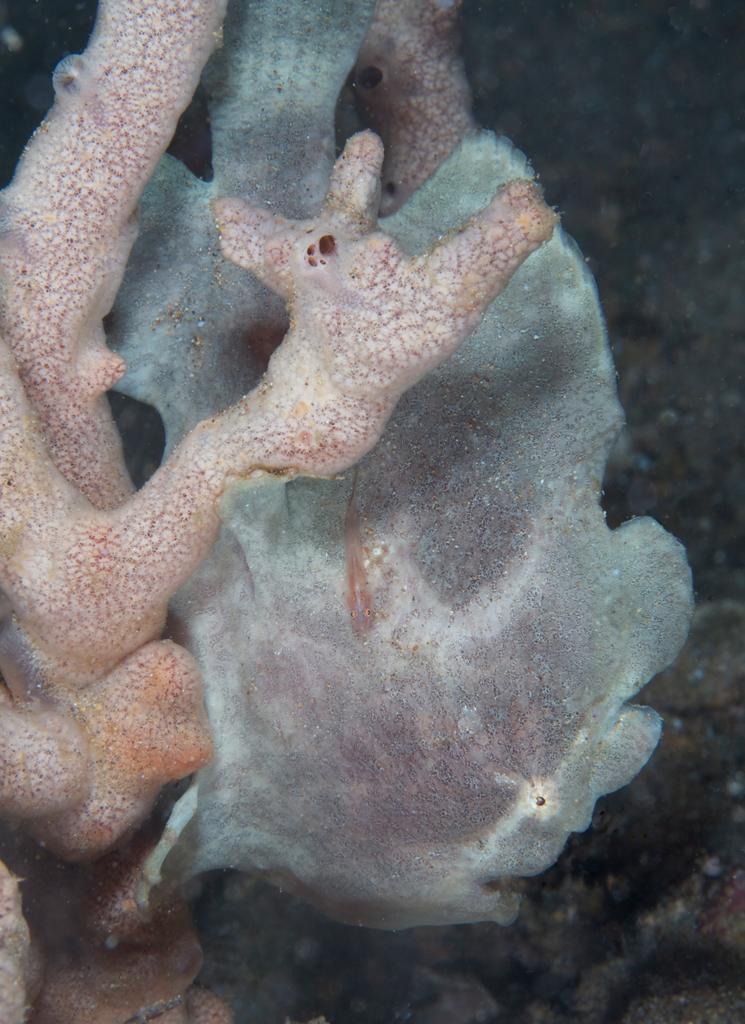Please provide a concise description of this image. In this image we can see an underwater environment. 